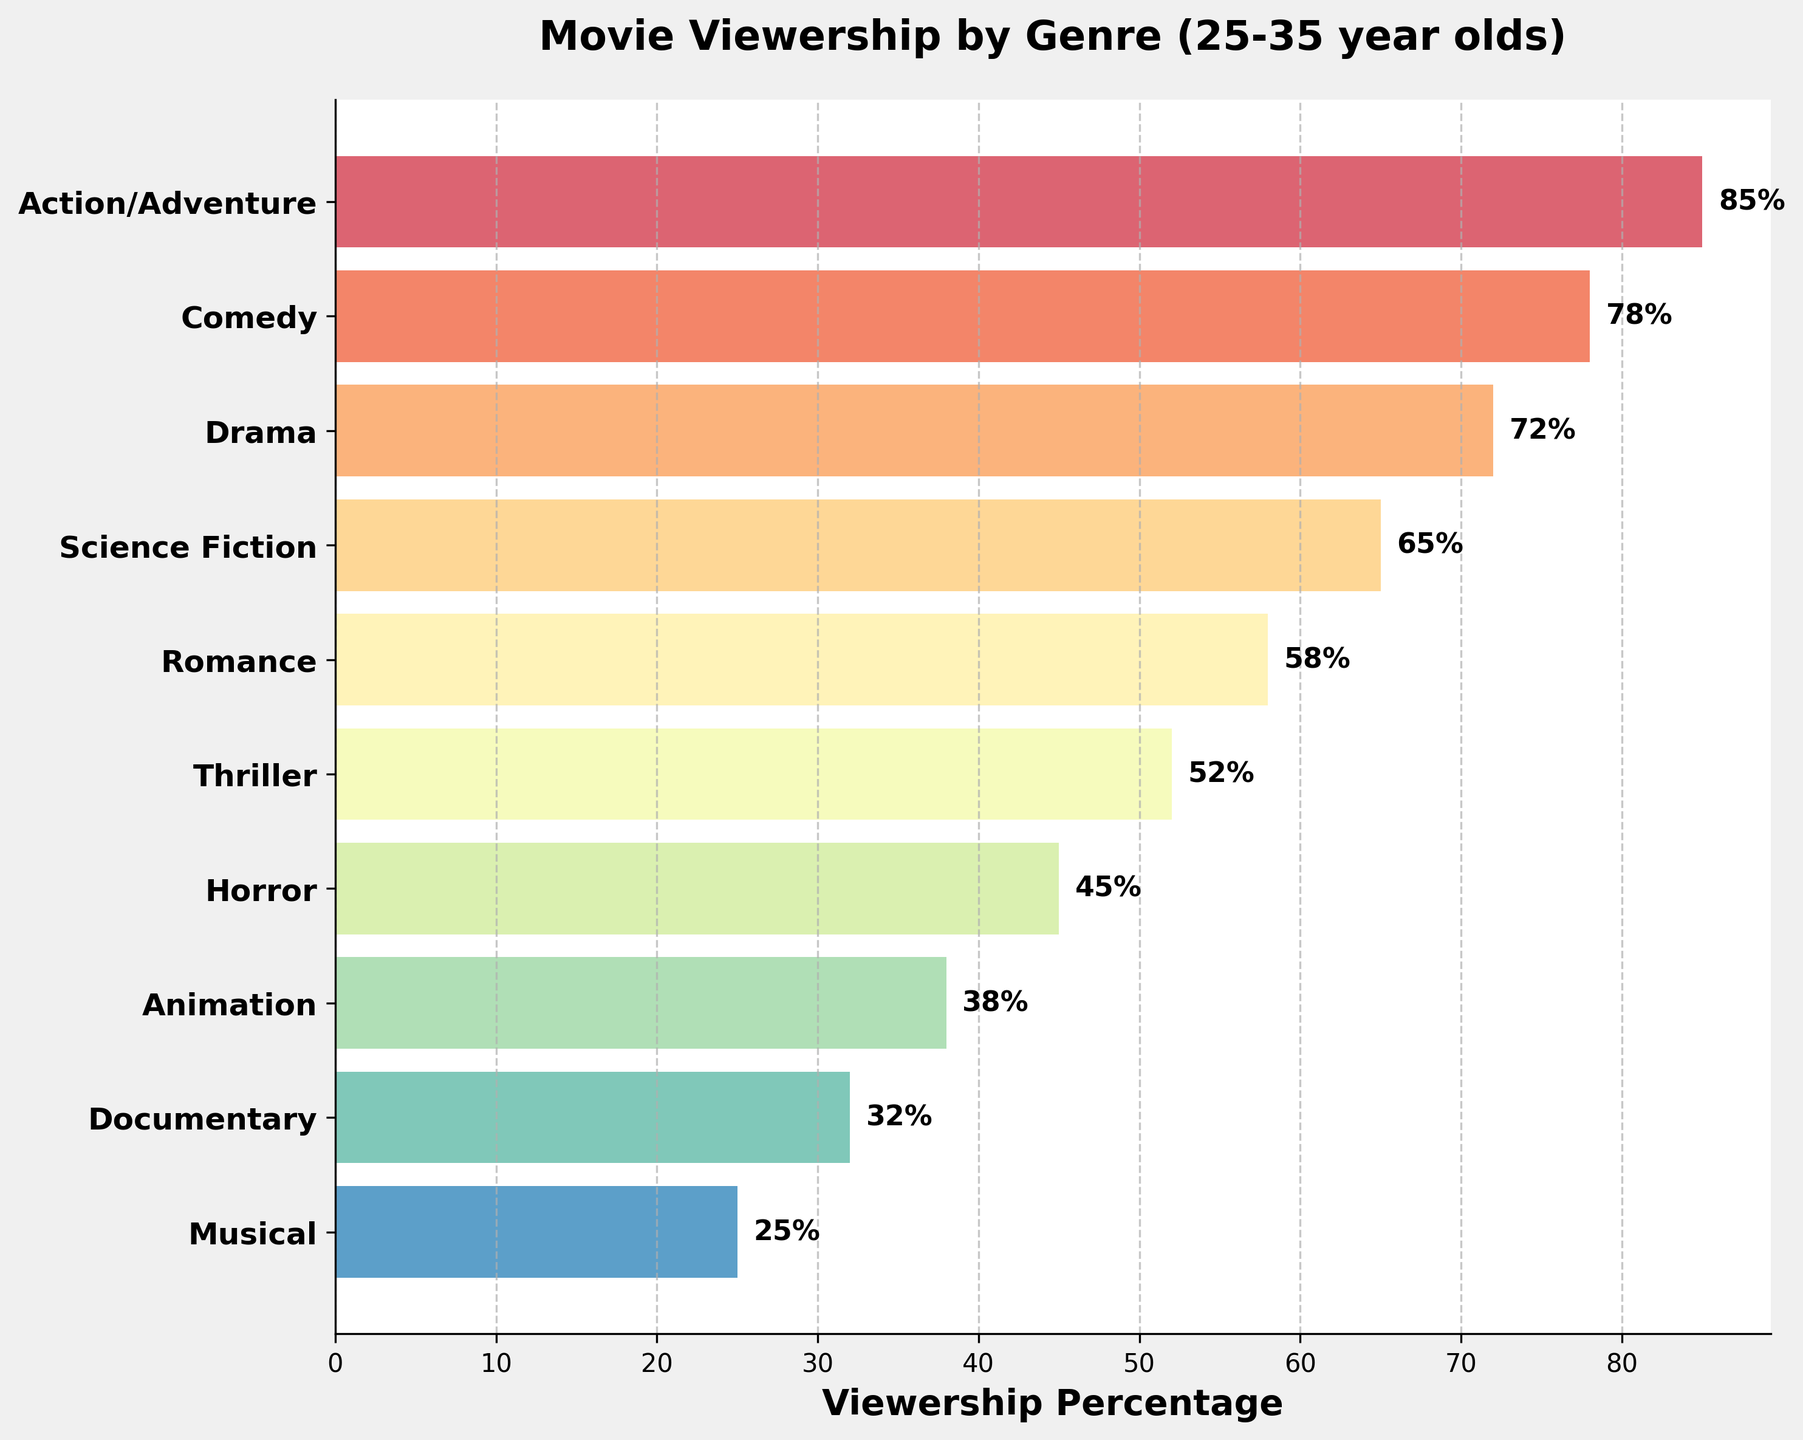What is the most popular movie genre among 25-35 year olds according to the chart? The chart shows the genres along the y-axis and viewership percentages along the x-axis. The most popular genre is at the top of the funnel.
Answer: Action/Adventure Which genre has the lowest viewership percentage among 25-35 year olds? The lowest viewership percentage is at the bottom of the funnel.
Answer: Musical What is the viewership percentage for Comedy movies? The label next to the Comedy bar displays the percentage value.
Answer: 78% How many genres have a viewership percentage above 50%? Count the bars that have a percentage value greater than 50%. The genres are Action/Adventure, Comedy, Drama, Science Fiction, Romance, and Thriller.
Answer: 6 How much higher is the viewership percentage for Action/Adventure compared to Horror? Subtract the viewership percentage of Horror from that of Action/Adventure (85 - 45).
Answer: 40% Which genres have a viewership percentage between 50% and 70%? Find the bars that fall within the 50-70% range: Science Fiction, Romance, and Thriller.
Answer: Science Fiction, Romance, and Thriller Compare the viewership percentages of Drama and Documentary. Look at the percentage values for both genres: Drama (72%) and Documentary (32%). Drama has a higher viewership percentage.
Answer: Drama What is the average viewership percentage of Action/Adventure, Comedy, and Drama? Add the percentages of these genres (85 + 78 + 72) and divide by 3: (85 + 78 + 72) / 3 = 235 / 3.
Answer: 78.33 Is Science Fiction more popular than Romance? Compare the viewership percentages: Science Fiction (65%) and Romance (58%). Science Fiction has a higher percentage.
Answer: Yes What is the total viewership percentage for the least three popular genres? Add the percentages of Animation, Documentary, and Musical (38 + 32 + 25) to get 95%.
Answer: 95% 